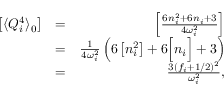Convert formula to latex. <formula><loc_0><loc_0><loc_500><loc_500>\begin{array} { r l r } { \left [ \langle Q _ { i } ^ { 4 } \rangle _ { 0 } \right ] } & { = } & { \left [ \frac { 6 n _ { i } ^ { 2 } + 6 n _ { i } + 3 } { 4 \omega _ { i } ^ { 2 } } \right ] } \\ & { = } & { \frac { 1 } { 4 \omega _ { i } ^ { 2 } } \left ( 6 \left [ n _ { i } ^ { 2 } \right ] + 6 \left [ n _ { i } \right ] + 3 \right ) } \\ & { = } & { \frac { 3 ( f _ { i } + 1 / 2 ) ^ { 2 } } { \omega _ { i } ^ { 2 } } , } \end{array}</formula> 